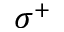<formula> <loc_0><loc_0><loc_500><loc_500>\sigma ^ { + }</formula> 